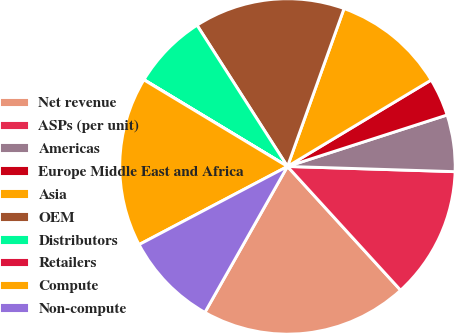Convert chart. <chart><loc_0><loc_0><loc_500><loc_500><pie_chart><fcel>Net revenue<fcel>ASPs (per unit)<fcel>Americas<fcel>Europe Middle East and Africa<fcel>Asia<fcel>OEM<fcel>Distributors<fcel>Retailers<fcel>Compute<fcel>Non-compute<nl><fcel>19.98%<fcel>12.72%<fcel>5.46%<fcel>3.65%<fcel>10.91%<fcel>14.54%<fcel>7.28%<fcel>0.02%<fcel>16.35%<fcel>9.09%<nl></chart> 